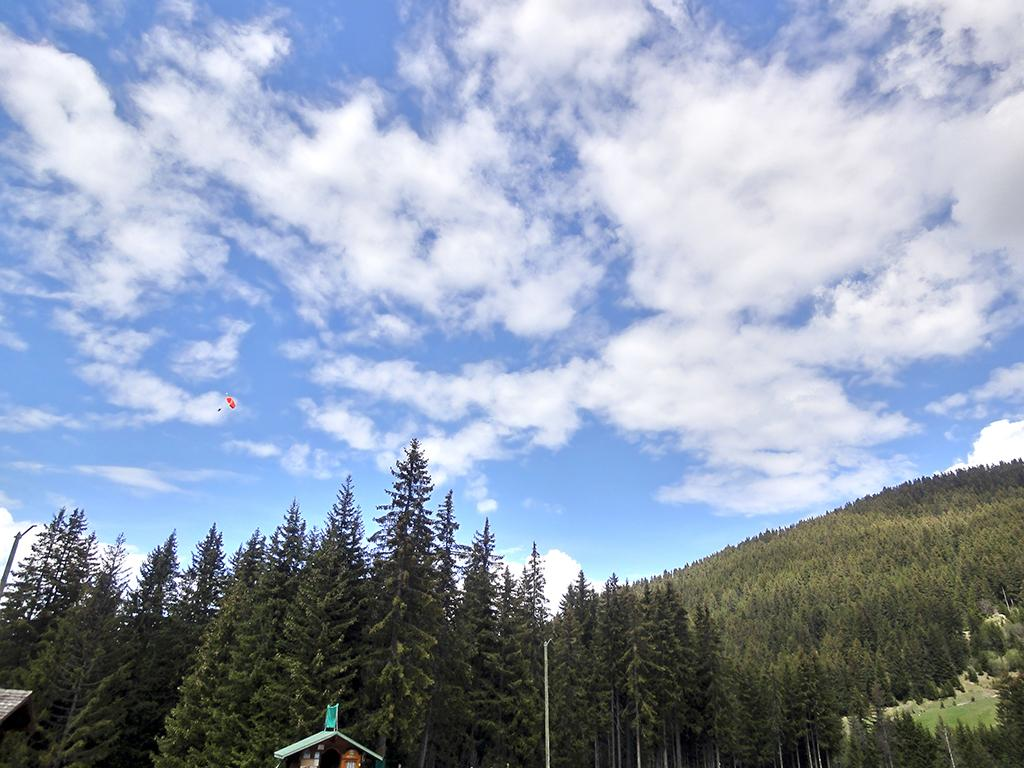What can be seen at the bottom of the image? There are trees and roofs at the bottom side of the image. What geographical feature is present in the image? There is a mountain in the image. What object appears to be descending from the sky? It appears to be a parachute in the image. What is visible in the background of the image? The sky is visible in the background of the image. Can you tell me how many clovers are growing on the mountain in the image? There is no mention of clovers in the image; the focus is on the mountain, parachute, and sky. What is the temperature like in the image? The provided facts do not mention the temperature or heat in the image. 